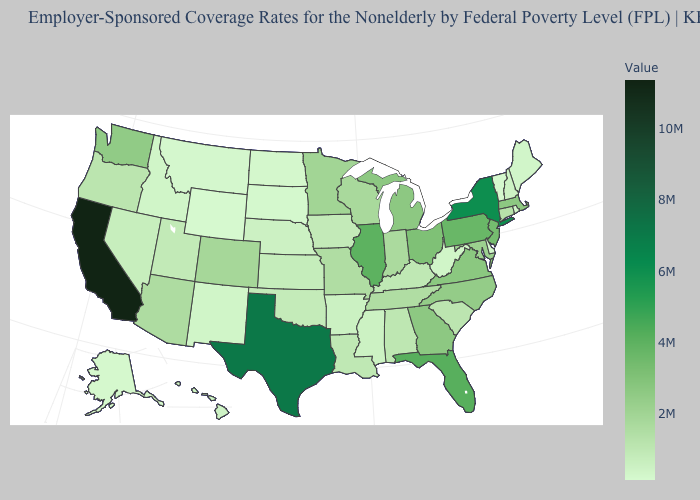Among the states that border Delaware , does Pennsylvania have the highest value?
Concise answer only. Yes. Among the states that border Delaware , does Pennsylvania have the highest value?
Short answer required. Yes. Does Wyoming have the lowest value in the West?
Concise answer only. Yes. Which states have the lowest value in the South?
Be succinct. Delaware. Which states have the lowest value in the USA?
Be succinct. Wyoming. 